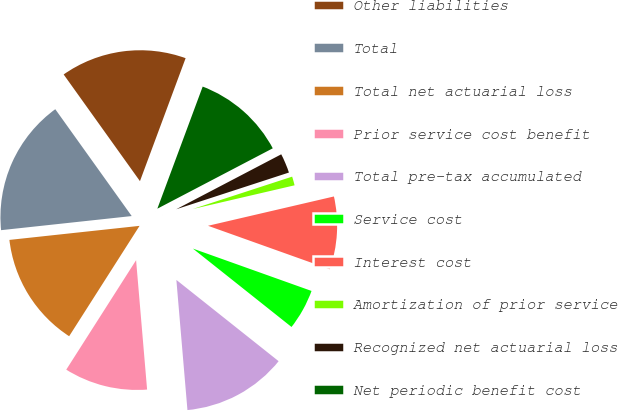<chart> <loc_0><loc_0><loc_500><loc_500><pie_chart><fcel>Other liabilities<fcel>Total<fcel>Total net actuarial loss<fcel>Prior service cost benefit<fcel>Total pre-tax accumulated<fcel>Service cost<fcel>Interest cost<fcel>Amortization of prior service<fcel>Recognized net actuarial loss<fcel>Net periodic benefit cost<nl><fcel>15.54%<fcel>16.83%<fcel>14.25%<fcel>10.39%<fcel>12.96%<fcel>5.23%<fcel>9.1%<fcel>1.37%<fcel>2.66%<fcel>11.67%<nl></chart> 